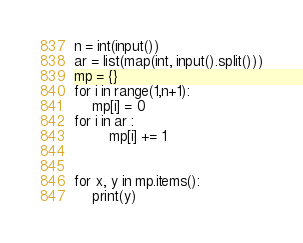<code> <loc_0><loc_0><loc_500><loc_500><_Python_>n = int(input())
ar = list(map(int, input().split()))
mp = {}
for i in range(1,n+1):
    mp[i] = 0
for i in ar :
        mp[i] += 1


for x, y in mp.items():
    print(y)</code> 